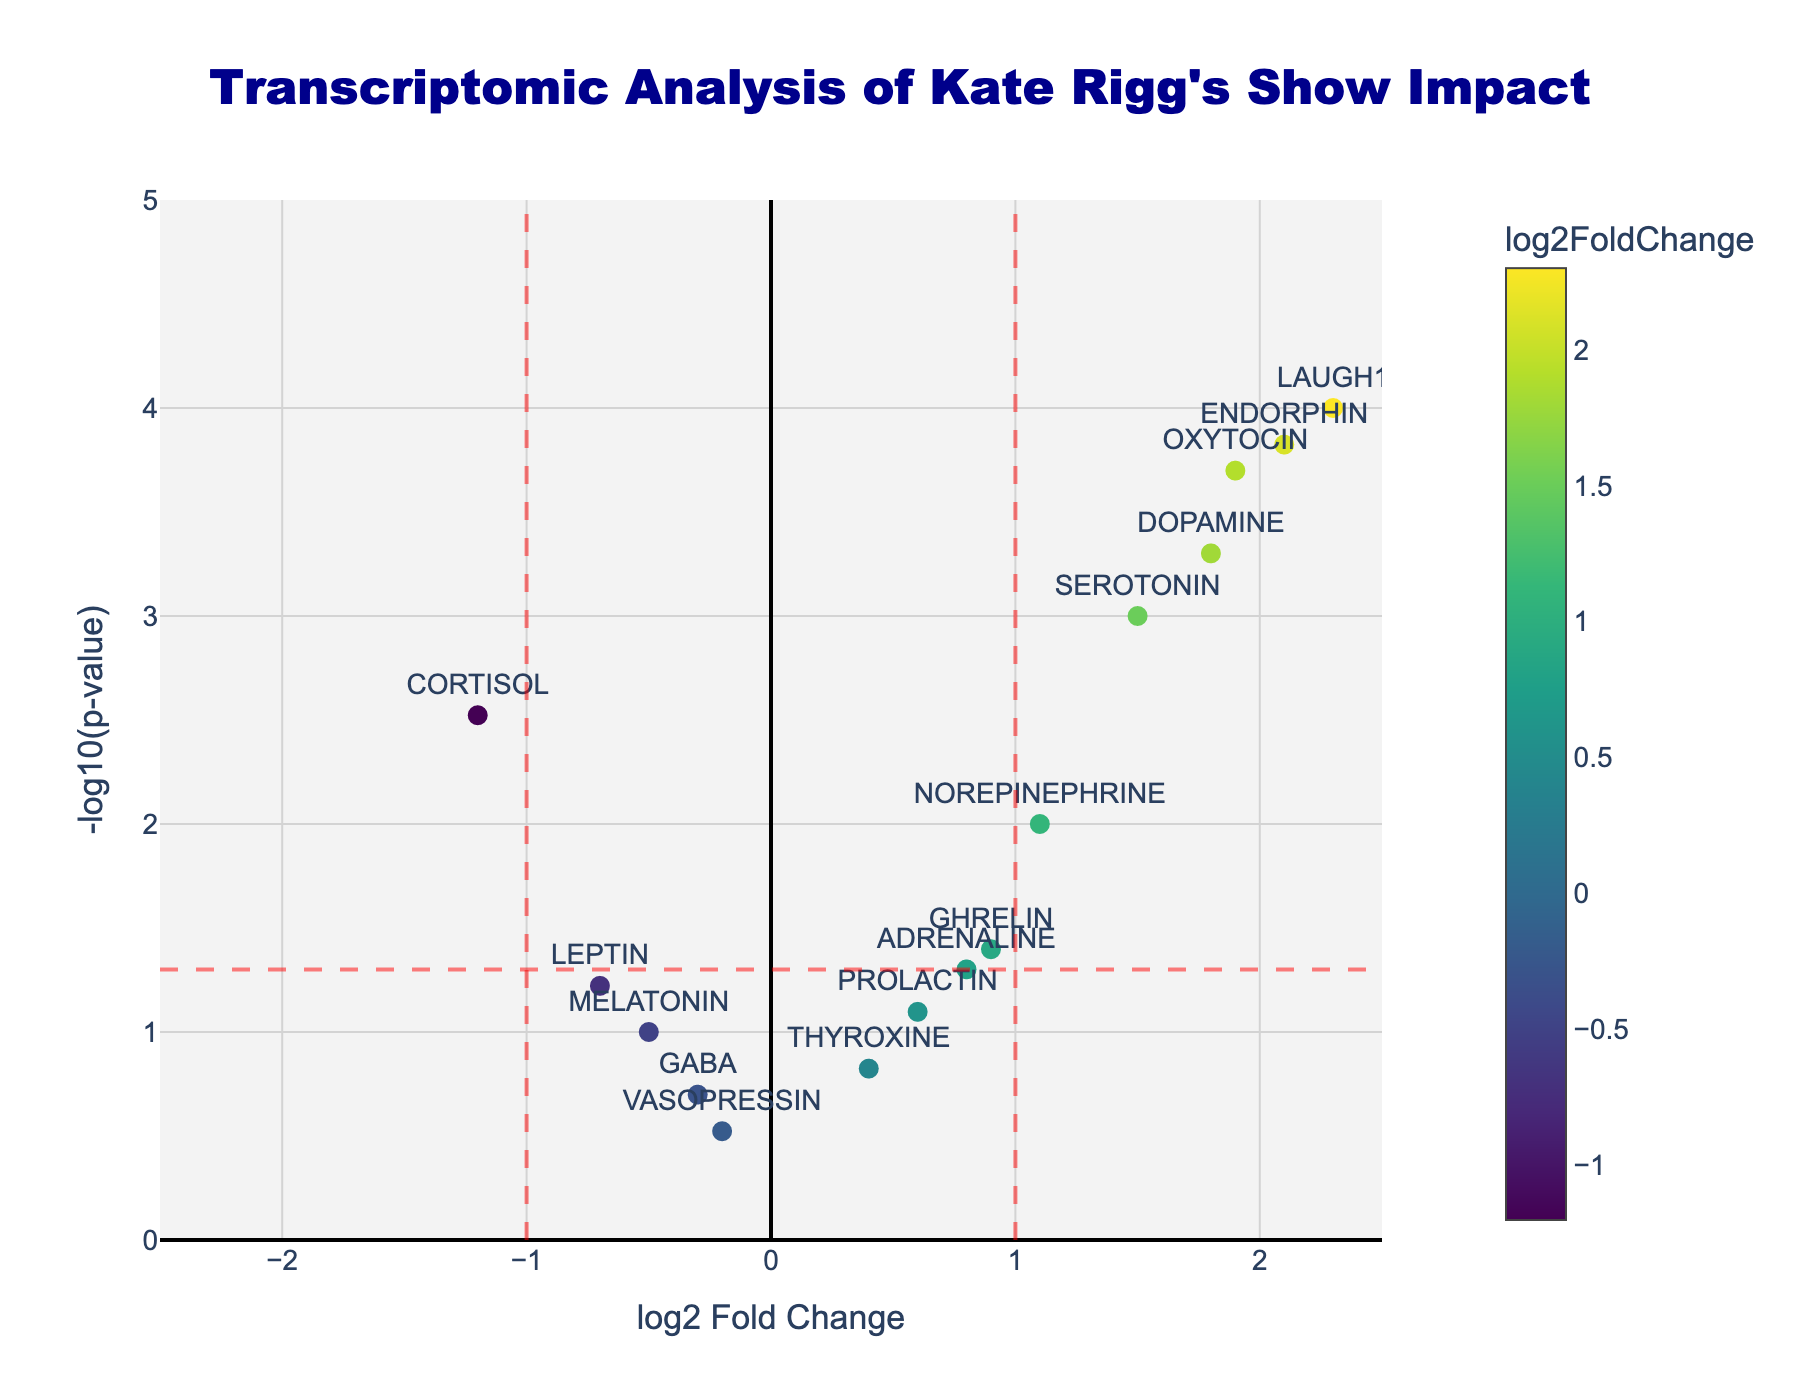What is the title of the plot? The title of the plot is located at the top and is formatted with font size and color.
Answer: Transcriptomic Analysis of Kate Rigg's Show Impact What does the x-axis represent? The x-axis label is explicitly stated at the bottom of the x-axis.
Answer: log2 Fold Change What is the y-axis title? The y-axis title can be identified on the left side of the y-axis.
Answer: -log10(p-value) How many genes have a log2FoldChange greater than 1? To answer this, we count the data points where the log2FoldChange is greater than 1 along the x-axis.
Answer: 6 Which gene has the highest -log10(p-value)? By observing the y-axis, we can identify the gene at the highest point vertically.
Answer: LAUGH1 What is the log2FoldChange of SEROTONIN? Locate the point labeled SEROTONIN and observe its position on the x-axis.
Answer: 1.5 Which genes are considered highly significant (p-value < 0.05) and have a log2FoldChange more positive than 1? Locate data points above the red horizontal line (significance threshold) with log2FoldChange greater than 1 on the x-axis.
Answer: LAUGH1, OXYTOCIN, DOPAMINE, ENDORPHIN Are there any genes with a negative log2FoldChange and significant p-values (p-value < 0.05)? Look for data points to the left of the vertical red dash line at -1 and above the horizontal red dash line.
Answer: CORTISOL What is the color of the most upregulated gene? The most upregulated gene has the highest log2FoldChange. Identify its color based on the color scale.
Answer: Dark Yellow Which gene has the lowest significance? Identify the lowest positioned point on the y-axis, which corresponds to the highest p-value.
Answer: VASOPRESSIN 